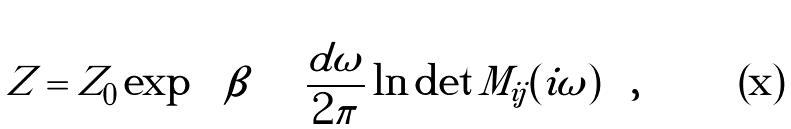<formula> <loc_0><loc_0><loc_500><loc_500>Z = Z _ { 0 } \exp \, \left [ \beta \int \frac { d \omega } { 2 \pi } \ln \det M _ { i j } ( i \omega ) \right ] ,</formula> 